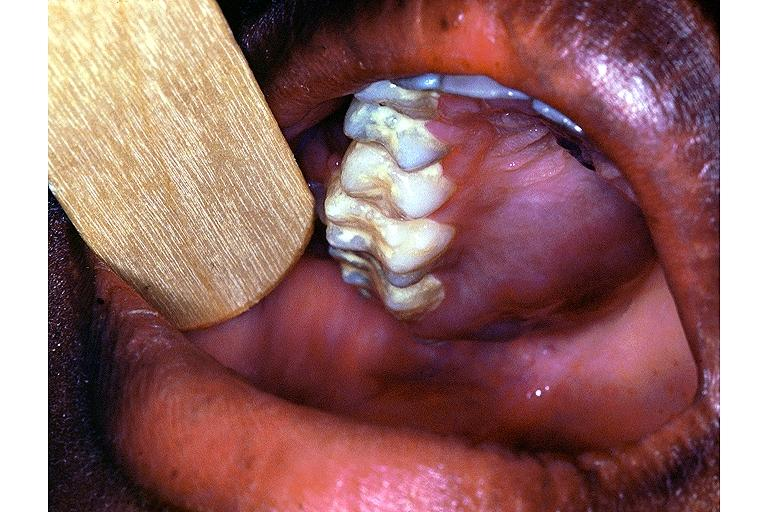what is present?
Answer the question using a single word or phrase. Oral 